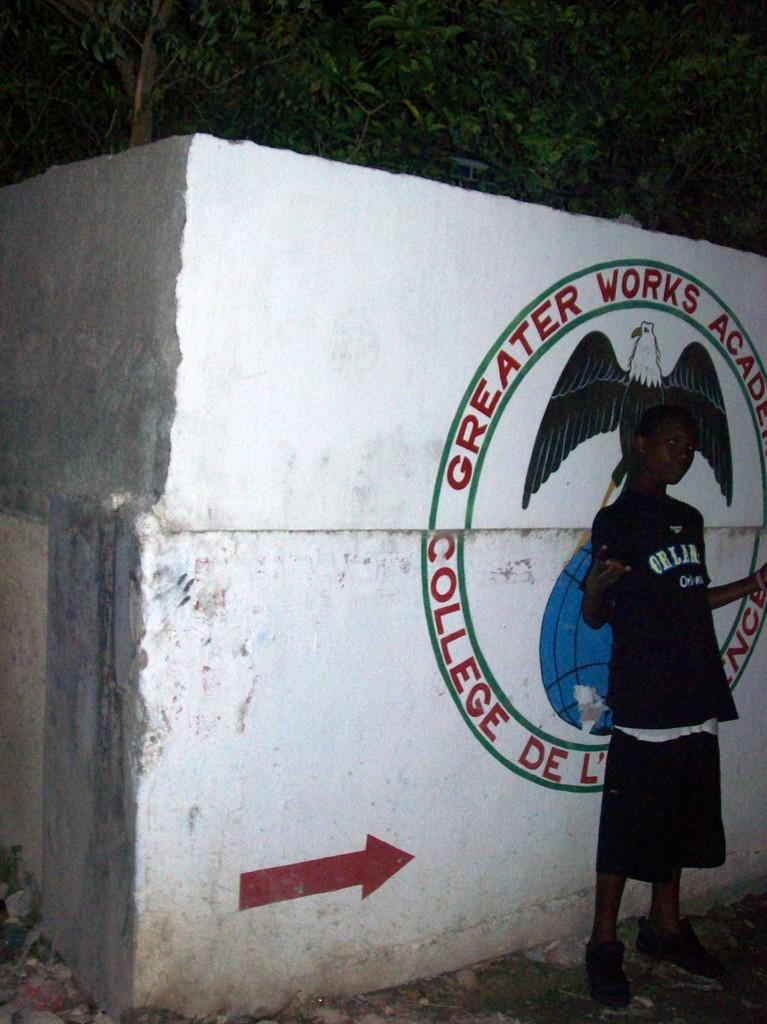<image>
Share a concise interpretation of the image provided. A MURAL ON A WALL THAT READS GREATER WORKS ACADEMY COLLEGE 